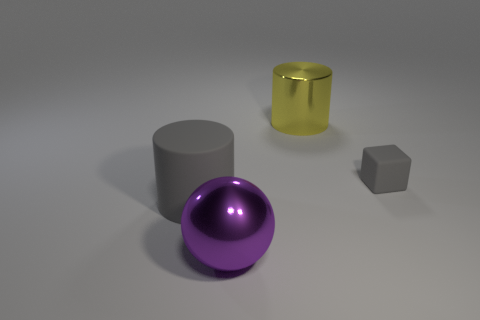There is a object that is the same color as the matte cube; what material is it?
Provide a short and direct response. Rubber. Are there any other things that are the same size as the matte cube?
Make the answer very short. No. What number of things are either large cylinders that are in front of the yellow shiny thing or big objects behind the large gray object?
Make the answer very short. 2. Is the number of tiny gray rubber cubes less than the number of things?
Offer a very short reply. Yes. How many things are either small green blocks or gray matte objects?
Offer a terse response. 2. Does the yellow shiny object have the same shape as the big gray matte object?
Make the answer very short. Yes. Does the metallic thing that is to the right of the big purple sphere have the same size as the gray rubber cylinder left of the big purple shiny sphere?
Provide a short and direct response. Yes. What is the large object that is on the right side of the large matte cylinder and behind the purple metal object made of?
Offer a terse response. Metal. Is there anything else that is the same color as the small thing?
Your answer should be very brief. Yes. Is the number of yellow cylinders that are in front of the yellow cylinder less than the number of small gray matte cubes?
Ensure brevity in your answer.  Yes. 